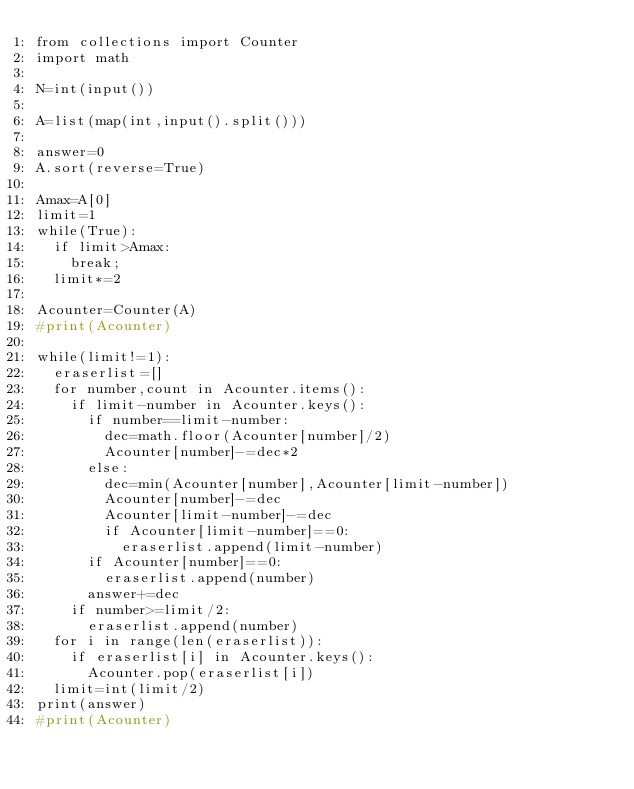<code> <loc_0><loc_0><loc_500><loc_500><_Python_>from collections import Counter
import math

N=int(input())

A=list(map(int,input().split()))

answer=0
A.sort(reverse=True)

Amax=A[0]
limit=1
while(True):
  if limit>Amax:
    break;
  limit*=2

Acounter=Counter(A)
#print(Acounter)

while(limit!=1):
  eraserlist=[]
  for number,count in Acounter.items():
    if limit-number in Acounter.keys():
      if number==limit-number:
        dec=math.floor(Acounter[number]/2)
        Acounter[number]-=dec*2
      else:
        dec=min(Acounter[number],Acounter[limit-number])
        Acounter[number]-=dec
        Acounter[limit-number]-=dec
        if Acounter[limit-number]==0:
          eraserlist.append(limit-number)
      if Acounter[number]==0:
        eraserlist.append(number)
      answer+=dec
    if number>=limit/2:
      eraserlist.append(number)
  for i in range(len(eraserlist)):
    if eraserlist[i] in Acounter.keys():
      Acounter.pop(eraserlist[i])
  limit=int(limit/2)
print(answer)
#print(Acounter)</code> 